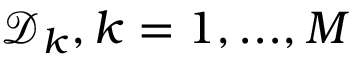Convert formula to latex. <formula><loc_0><loc_0><loc_500><loc_500>\mathcal { D } _ { k } , k = 1 , \dots , M</formula> 